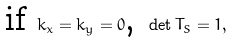<formula> <loc_0><loc_0><loc_500><loc_500>\text {if } k _ { x } = k _ { y } = 0 \text {, } \det T _ { S } = 1 ,</formula> 